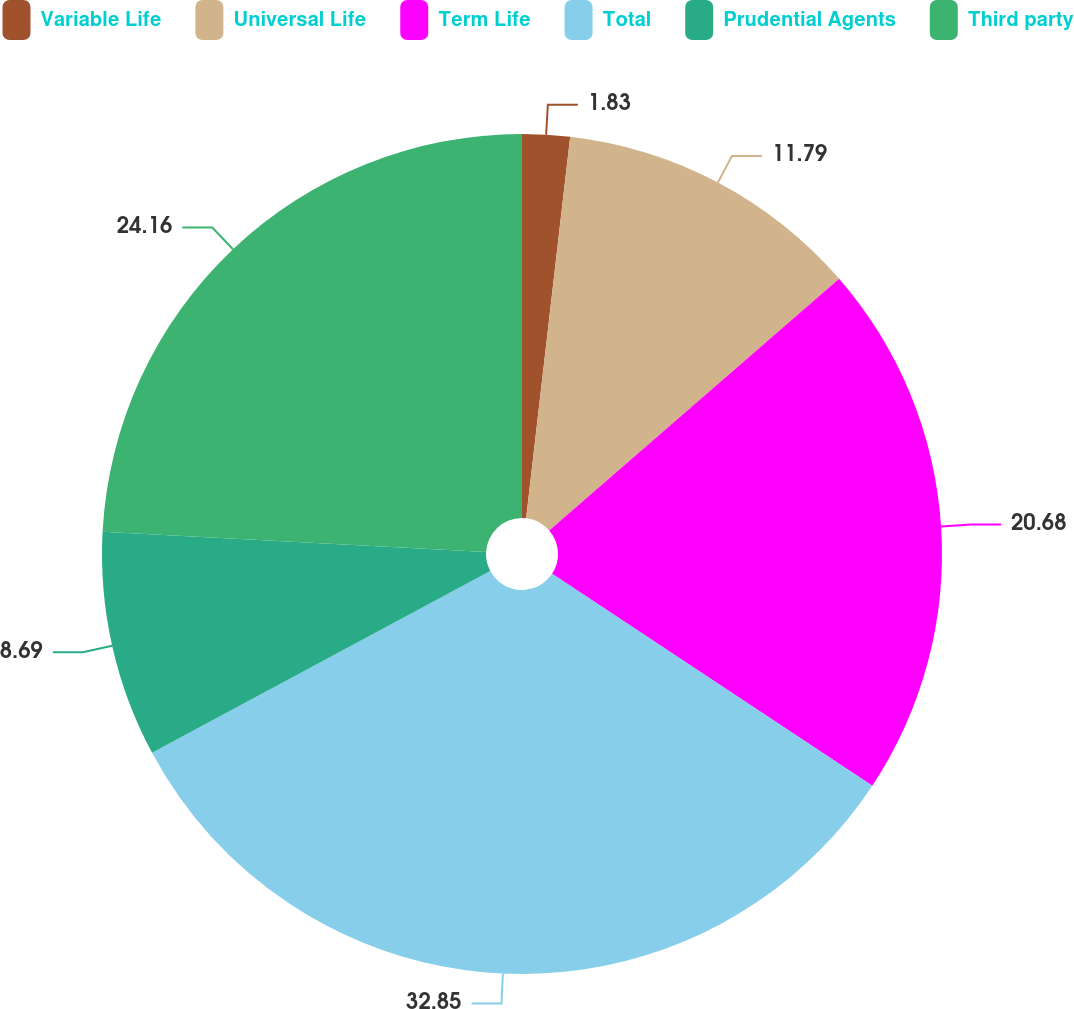<chart> <loc_0><loc_0><loc_500><loc_500><pie_chart><fcel>Variable Life<fcel>Universal Life<fcel>Term Life<fcel>Total<fcel>Prudential Agents<fcel>Third party<nl><fcel>1.83%<fcel>11.79%<fcel>20.68%<fcel>32.85%<fcel>8.69%<fcel>24.16%<nl></chart> 